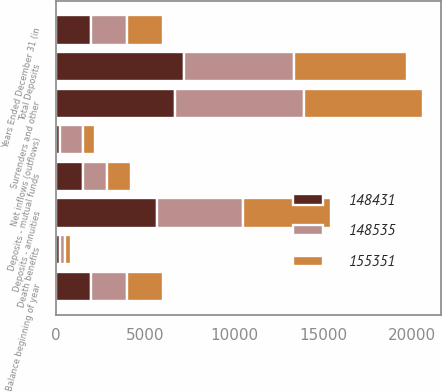Convert chart to OTSL. <chart><loc_0><loc_0><loc_500><loc_500><stacked_bar_chart><ecel><fcel>Years Ended December 31 (in<fcel>Balance beginning of year<fcel>Deposits - annuities<fcel>Deposits - mutual funds<fcel>Total Deposits<fcel>Surrenders and other<fcel>Death benefits<fcel>Net inflows (outflows)<nl><fcel>155351<fcel>2010<fcel>2009<fcel>4937<fcel>1372<fcel>6309<fcel>6647<fcel>317<fcel>655<nl><fcel>148535<fcel>2009<fcel>2009<fcel>4856<fcel>1345<fcel>6201<fcel>7233<fcel>275<fcel>1307<nl><fcel>148431<fcel>2008<fcel>2009<fcel>5661<fcel>1520<fcel>7181<fcel>6693<fcel>246<fcel>242<nl></chart> 